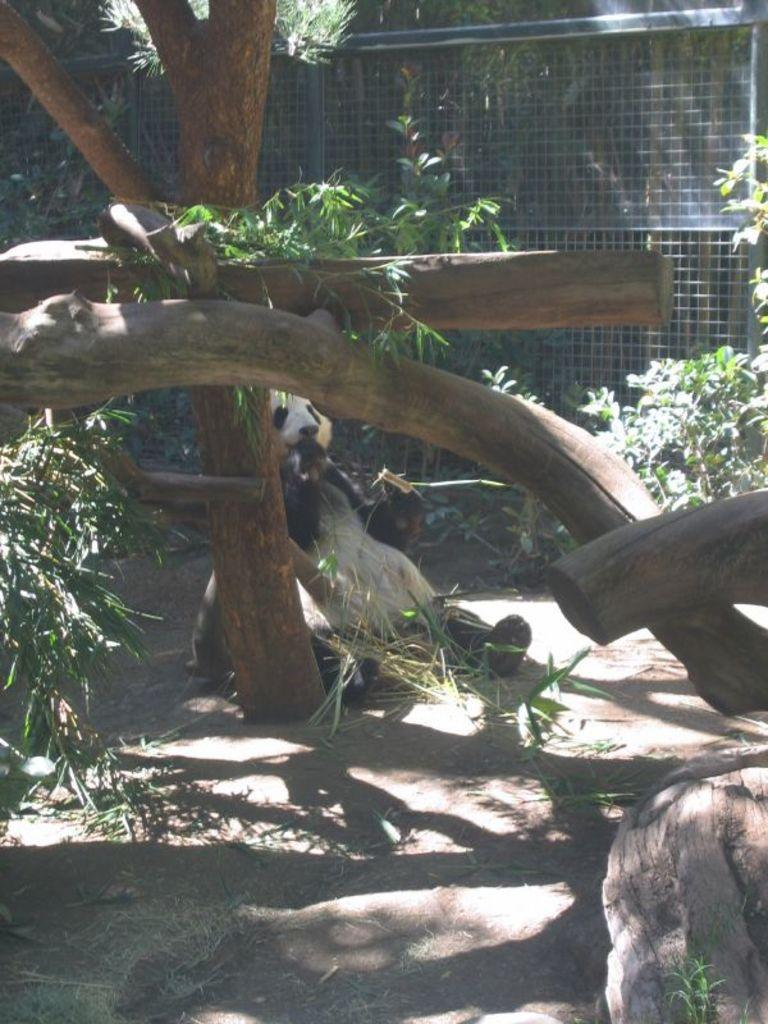What animal is in the center of the image? There is a panda in the center of the image. What type of natural structure can be seen in the image? There is a tree in the image. What man-made structure is present in the image? There is a fence in the image. What type of vegetation is visible in the image? There are plants and tree trunks in the image. What is visible behind the fence in the image? Trees are visible behind the fence. What type of advertisement can be seen on the queen's hat in the image? There is no queen or advertisement present in the image; it features a panda and various natural and man-made structures. 